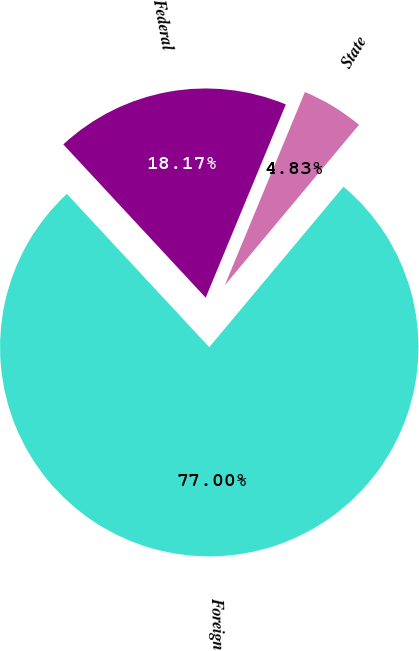Convert chart. <chart><loc_0><loc_0><loc_500><loc_500><pie_chart><fcel>Federal<fcel>State<fcel>Foreign<nl><fcel>18.17%<fcel>4.83%<fcel>77.0%<nl></chart> 